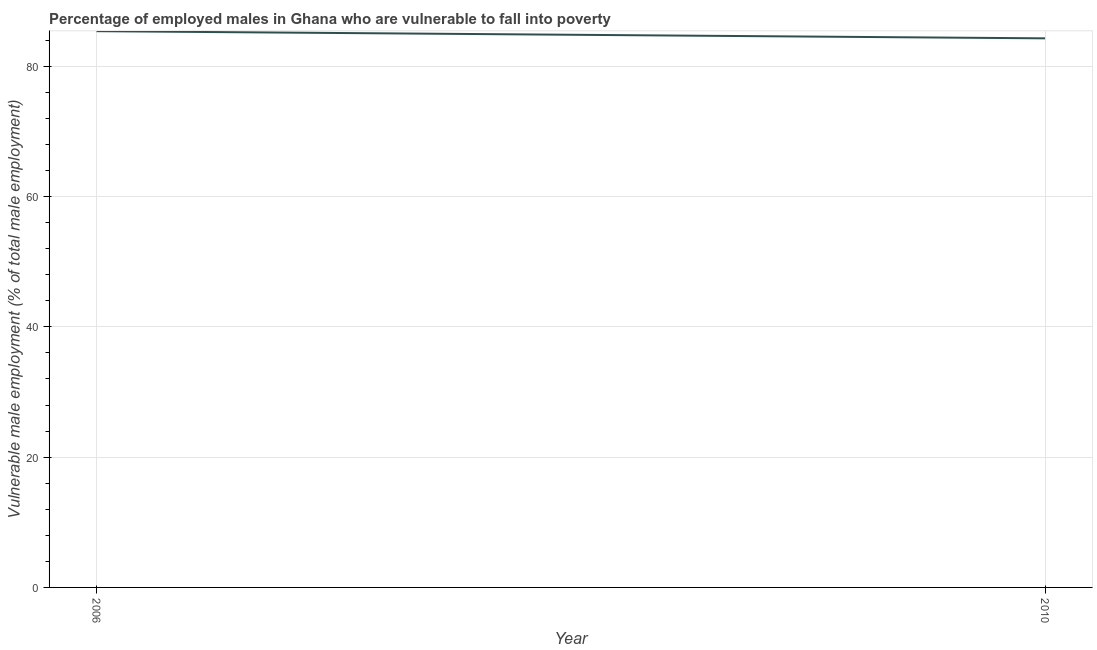What is the percentage of employed males who are vulnerable to fall into poverty in 2010?
Provide a short and direct response. 84.3. Across all years, what is the maximum percentage of employed males who are vulnerable to fall into poverty?
Your response must be concise. 85.4. Across all years, what is the minimum percentage of employed males who are vulnerable to fall into poverty?
Ensure brevity in your answer.  84.3. In which year was the percentage of employed males who are vulnerable to fall into poverty maximum?
Offer a terse response. 2006. What is the sum of the percentage of employed males who are vulnerable to fall into poverty?
Your response must be concise. 169.7. What is the difference between the percentage of employed males who are vulnerable to fall into poverty in 2006 and 2010?
Offer a very short reply. 1.1. What is the average percentage of employed males who are vulnerable to fall into poverty per year?
Provide a short and direct response. 84.85. What is the median percentage of employed males who are vulnerable to fall into poverty?
Offer a terse response. 84.85. Do a majority of the years between 2010 and 2006 (inclusive) have percentage of employed males who are vulnerable to fall into poverty greater than 48 %?
Your answer should be compact. No. What is the ratio of the percentage of employed males who are vulnerable to fall into poverty in 2006 to that in 2010?
Offer a very short reply. 1.01. In how many years, is the percentage of employed males who are vulnerable to fall into poverty greater than the average percentage of employed males who are vulnerable to fall into poverty taken over all years?
Your answer should be very brief. 1. How many lines are there?
Your answer should be very brief. 1. How many years are there in the graph?
Offer a very short reply. 2. Does the graph contain grids?
Offer a terse response. Yes. What is the title of the graph?
Your response must be concise. Percentage of employed males in Ghana who are vulnerable to fall into poverty. What is the label or title of the Y-axis?
Your answer should be very brief. Vulnerable male employment (% of total male employment). What is the Vulnerable male employment (% of total male employment) of 2006?
Offer a very short reply. 85.4. What is the Vulnerable male employment (% of total male employment) of 2010?
Ensure brevity in your answer.  84.3. What is the difference between the Vulnerable male employment (% of total male employment) in 2006 and 2010?
Give a very brief answer. 1.1. 